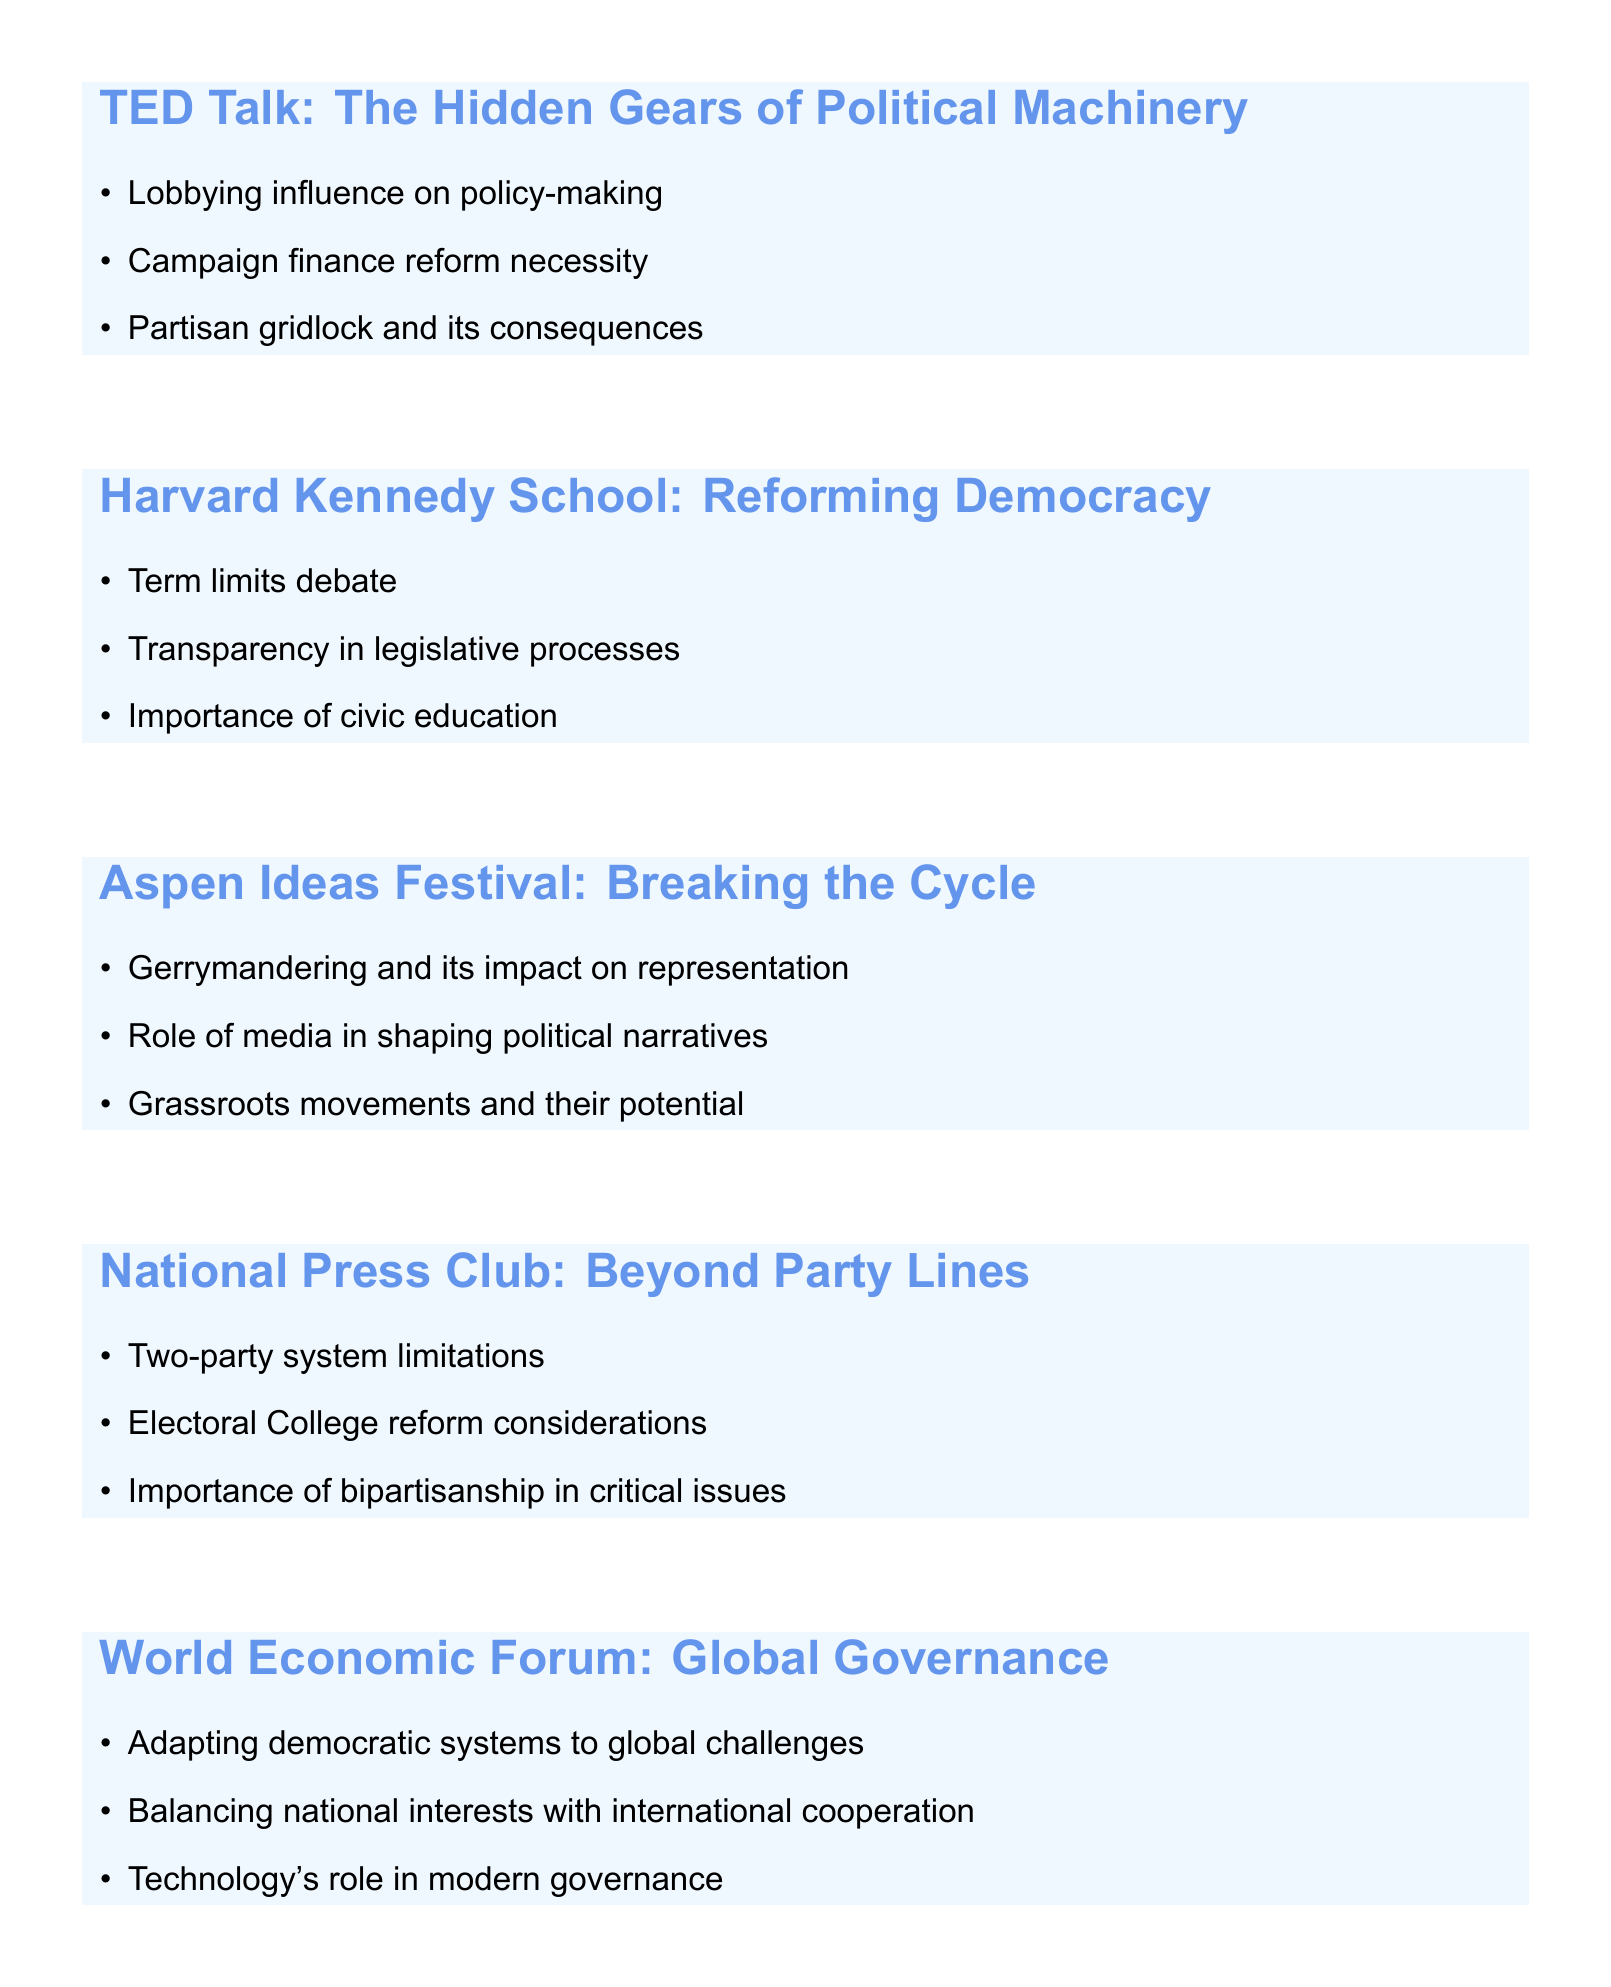What is the topic of the TED Talk? The topic of the TED Talk is provided in the document under the event title.
Answer: The Hidden Gears of Political Machinery: An Insider's Perspective What is one of the key points discussed at the Aspen Ideas Festival? Key points for each speaking engagement are listed, and this question asks for one from the Aspen Ideas Festival.
Answer: Gerrymandering and its impact on representation How many speaking engagements are listed in the document? The total number of events can be counted from the document.
Answer: Five What is the topic of the speaking engagement at the National Press Club? This question requires looking for the specific topic provided in the document for that event.
Answer: Beyond Party Lines: Addressing Systemic Flaws in American Politics What is a key point related to media discussed at the Aspen Ideas Festival? The document lists specific key points for each event, including this one for the Aspen Ideas Festival.
Answer: Role of media in shaping political narratives Which institution is associated with the engagement titled 'Reforming Democracy'? The document associates each event with a specific institution, making it possible to identify this one.
Answer: Harvard Kennedy School of Government What is proposed for improving American politics according to the National Press Club Luncheon? The key points address systemic issues, making this aspect clear in the list.
Answer: Importance of bipartisanship in critical issues What is the main issue discussed at the event focused on global governance? The main issue is outlined in the key points of the event, focusing on global governance.
Answer: Adapting democratic systems to global challenges 